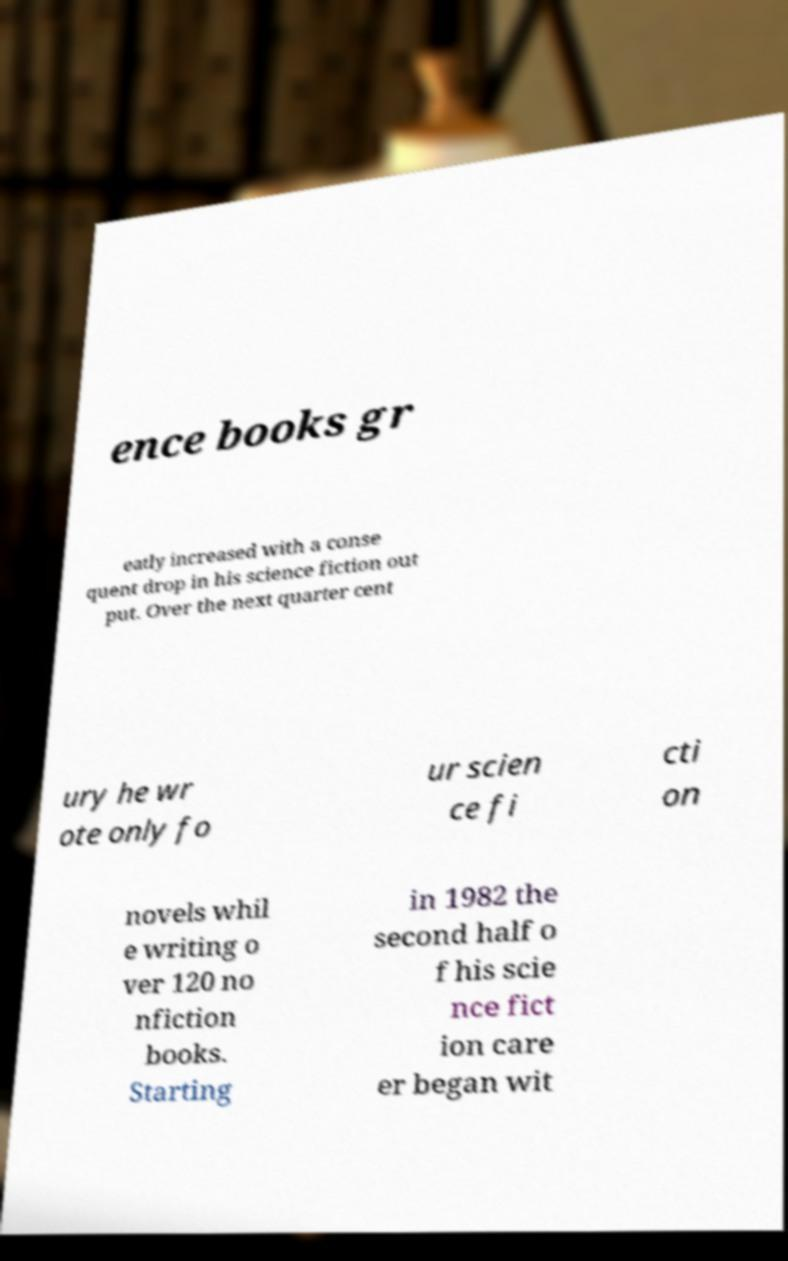For documentation purposes, I need the text within this image transcribed. Could you provide that? ence books gr eatly increased with a conse quent drop in his science fiction out put. Over the next quarter cent ury he wr ote only fo ur scien ce fi cti on novels whil e writing o ver 120 no nfiction books. Starting in 1982 the second half o f his scie nce fict ion care er began wit 